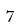Convert formula to latex. <formula><loc_0><loc_0><loc_500><loc_500>7</formula> 